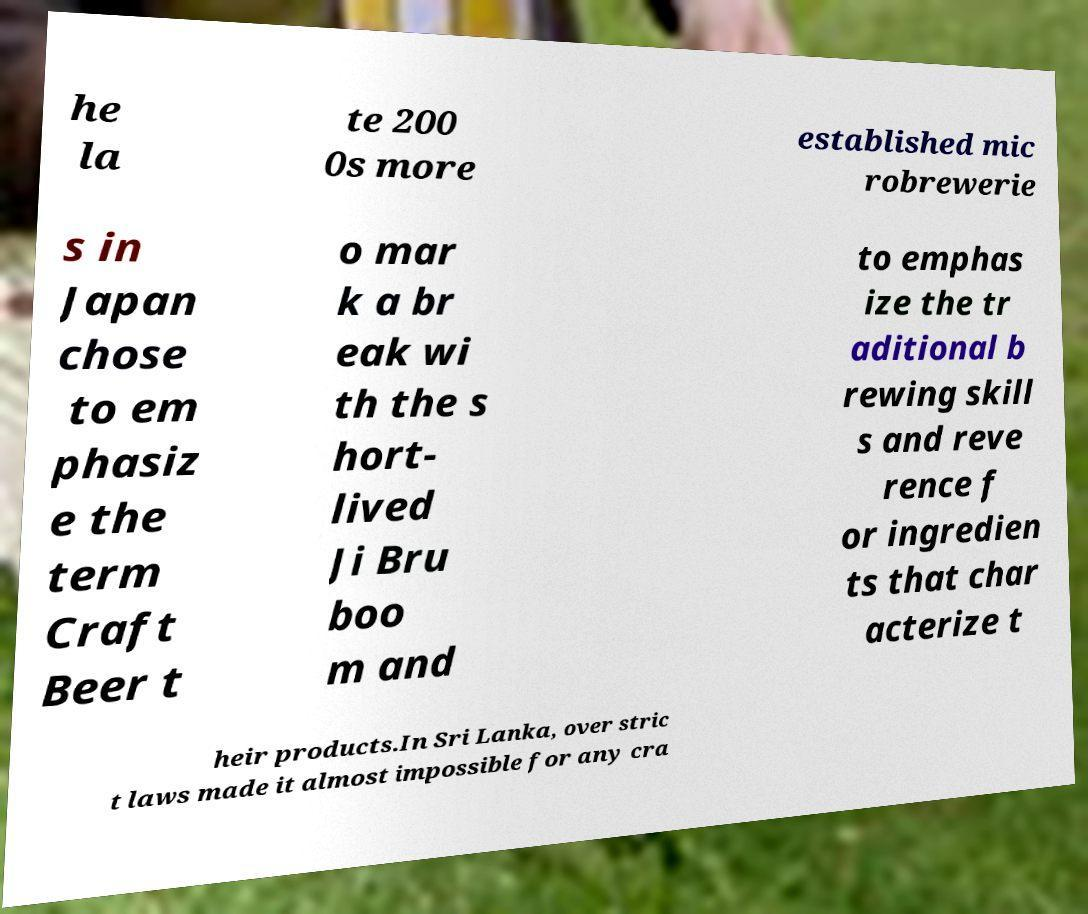I need the written content from this picture converted into text. Can you do that? he la te 200 0s more established mic robrewerie s in Japan chose to em phasiz e the term Craft Beer t o mar k a br eak wi th the s hort- lived Ji Bru boo m and to emphas ize the tr aditional b rewing skill s and reve rence f or ingredien ts that char acterize t heir products.In Sri Lanka, over stric t laws made it almost impossible for any cra 